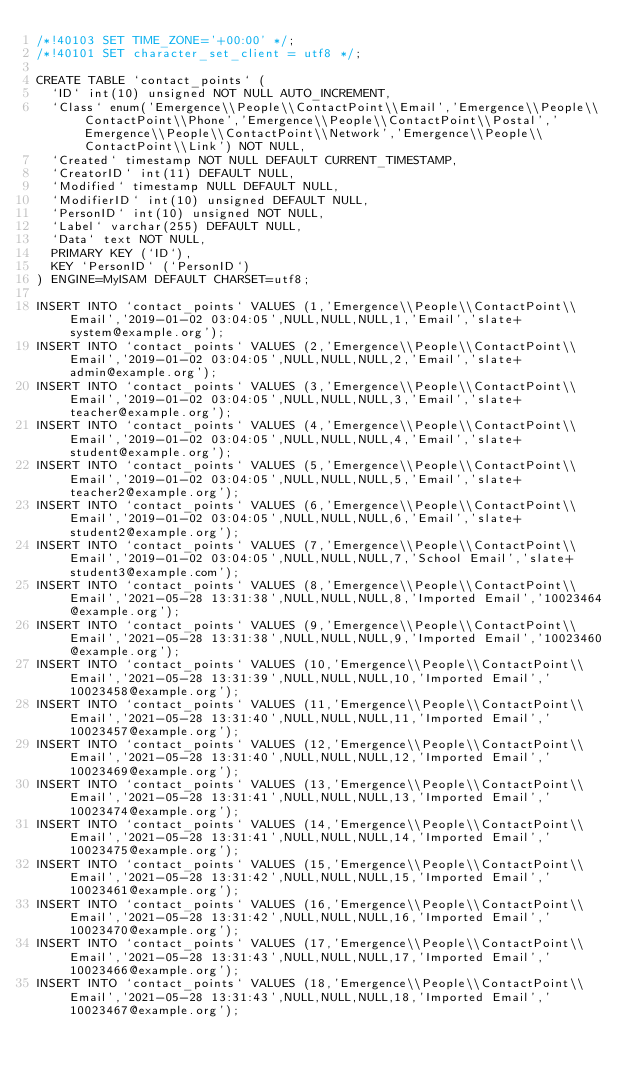<code> <loc_0><loc_0><loc_500><loc_500><_SQL_>/*!40103 SET TIME_ZONE='+00:00' */;
/*!40101 SET character_set_client = utf8 */;

CREATE TABLE `contact_points` (
  `ID` int(10) unsigned NOT NULL AUTO_INCREMENT,
  `Class` enum('Emergence\\People\\ContactPoint\\Email','Emergence\\People\\ContactPoint\\Phone','Emergence\\People\\ContactPoint\\Postal','Emergence\\People\\ContactPoint\\Network','Emergence\\People\\ContactPoint\\Link') NOT NULL,
  `Created` timestamp NOT NULL DEFAULT CURRENT_TIMESTAMP,
  `CreatorID` int(11) DEFAULT NULL,
  `Modified` timestamp NULL DEFAULT NULL,
  `ModifierID` int(10) unsigned DEFAULT NULL,
  `PersonID` int(10) unsigned NOT NULL,
  `Label` varchar(255) DEFAULT NULL,
  `Data` text NOT NULL,
  PRIMARY KEY (`ID`),
  KEY `PersonID` (`PersonID`)
) ENGINE=MyISAM DEFAULT CHARSET=utf8;

INSERT INTO `contact_points` VALUES (1,'Emergence\\People\\ContactPoint\\Email','2019-01-02 03:04:05',NULL,NULL,NULL,1,'Email','slate+system@example.org');
INSERT INTO `contact_points` VALUES (2,'Emergence\\People\\ContactPoint\\Email','2019-01-02 03:04:05',NULL,NULL,NULL,2,'Email','slate+admin@example.org');
INSERT INTO `contact_points` VALUES (3,'Emergence\\People\\ContactPoint\\Email','2019-01-02 03:04:05',NULL,NULL,NULL,3,'Email','slate+teacher@example.org');
INSERT INTO `contact_points` VALUES (4,'Emergence\\People\\ContactPoint\\Email','2019-01-02 03:04:05',NULL,NULL,NULL,4,'Email','slate+student@example.org');
INSERT INTO `contact_points` VALUES (5,'Emergence\\People\\ContactPoint\\Email','2019-01-02 03:04:05',NULL,NULL,NULL,5,'Email','slate+teacher2@example.org');
INSERT INTO `contact_points` VALUES (6,'Emergence\\People\\ContactPoint\\Email','2019-01-02 03:04:05',NULL,NULL,NULL,6,'Email','slate+student2@example.org');
INSERT INTO `contact_points` VALUES (7,'Emergence\\People\\ContactPoint\\Email','2019-01-02 03:04:05',NULL,NULL,NULL,7,'School Email','slate+student3@example.com');
INSERT INTO `contact_points` VALUES (8,'Emergence\\People\\ContactPoint\\Email','2021-05-28 13:31:38',NULL,NULL,NULL,8,'Imported Email','10023464@example.org');
INSERT INTO `contact_points` VALUES (9,'Emergence\\People\\ContactPoint\\Email','2021-05-28 13:31:38',NULL,NULL,NULL,9,'Imported Email','10023460@example.org');
INSERT INTO `contact_points` VALUES (10,'Emergence\\People\\ContactPoint\\Email','2021-05-28 13:31:39',NULL,NULL,NULL,10,'Imported Email','10023458@example.org');
INSERT INTO `contact_points` VALUES (11,'Emergence\\People\\ContactPoint\\Email','2021-05-28 13:31:40',NULL,NULL,NULL,11,'Imported Email','10023457@example.org');
INSERT INTO `contact_points` VALUES (12,'Emergence\\People\\ContactPoint\\Email','2021-05-28 13:31:40',NULL,NULL,NULL,12,'Imported Email','10023469@example.org');
INSERT INTO `contact_points` VALUES (13,'Emergence\\People\\ContactPoint\\Email','2021-05-28 13:31:41',NULL,NULL,NULL,13,'Imported Email','10023474@example.org');
INSERT INTO `contact_points` VALUES (14,'Emergence\\People\\ContactPoint\\Email','2021-05-28 13:31:41',NULL,NULL,NULL,14,'Imported Email','10023475@example.org');
INSERT INTO `contact_points` VALUES (15,'Emergence\\People\\ContactPoint\\Email','2021-05-28 13:31:42',NULL,NULL,NULL,15,'Imported Email','10023461@example.org');
INSERT INTO `contact_points` VALUES (16,'Emergence\\People\\ContactPoint\\Email','2021-05-28 13:31:42',NULL,NULL,NULL,16,'Imported Email','10023470@example.org');
INSERT INTO `contact_points` VALUES (17,'Emergence\\People\\ContactPoint\\Email','2021-05-28 13:31:43',NULL,NULL,NULL,17,'Imported Email','10023466@example.org');
INSERT INTO `contact_points` VALUES (18,'Emergence\\People\\ContactPoint\\Email','2021-05-28 13:31:43',NULL,NULL,NULL,18,'Imported Email','10023467@example.org');</code> 